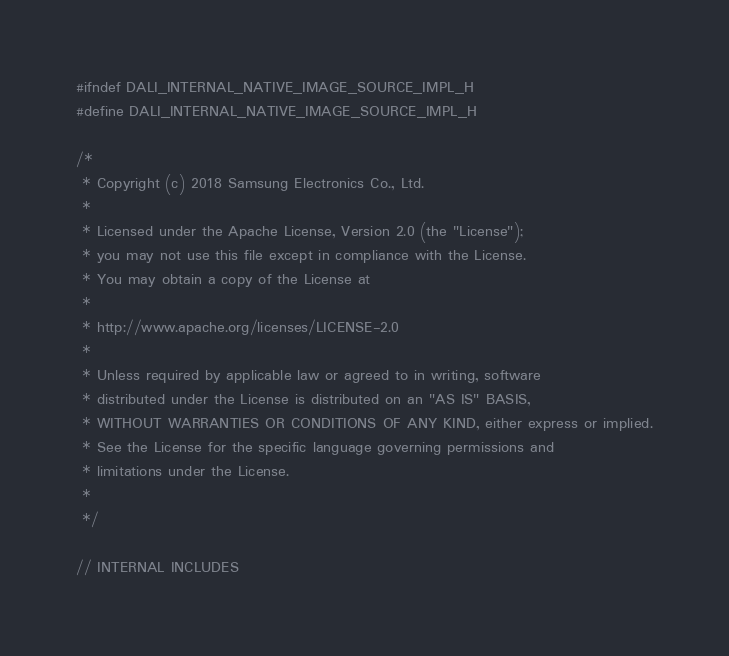<code> <loc_0><loc_0><loc_500><loc_500><_C_>#ifndef DALI_INTERNAL_NATIVE_IMAGE_SOURCE_IMPL_H
#define DALI_INTERNAL_NATIVE_IMAGE_SOURCE_IMPL_H

/*
 * Copyright (c) 2018 Samsung Electronics Co., Ltd.
 *
 * Licensed under the Apache License, Version 2.0 (the "License");
 * you may not use this file except in compliance with the License.
 * You may obtain a copy of the License at
 *
 * http://www.apache.org/licenses/LICENSE-2.0
 *
 * Unless required by applicable law or agreed to in writing, software
 * distributed under the License is distributed on an "AS IS" BASIS,
 * WITHOUT WARRANTIES OR CONDITIONS OF ANY KIND, either express or implied.
 * See the License for the specific language governing permissions and
 * limitations under the License.
 *
 */

// INTERNAL INCLUDES</code> 